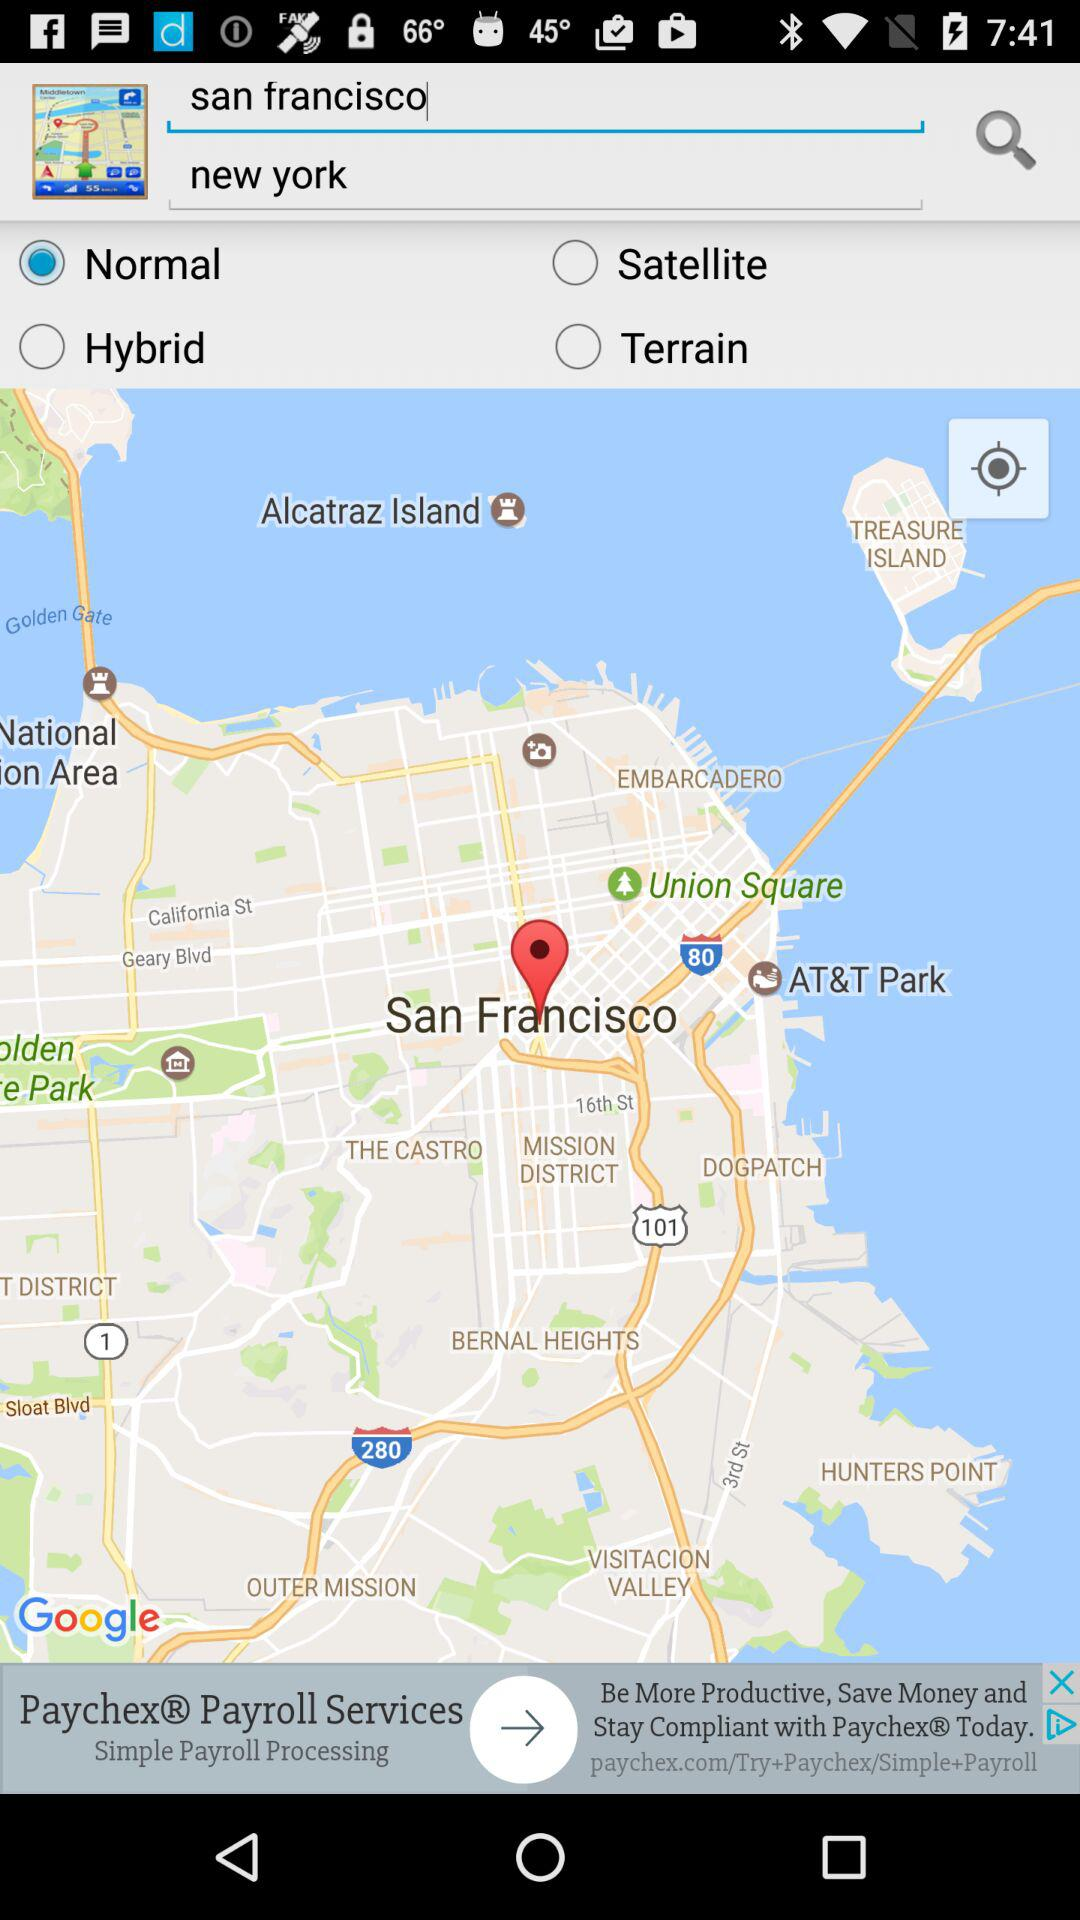What's the destination? The destination is New York. 